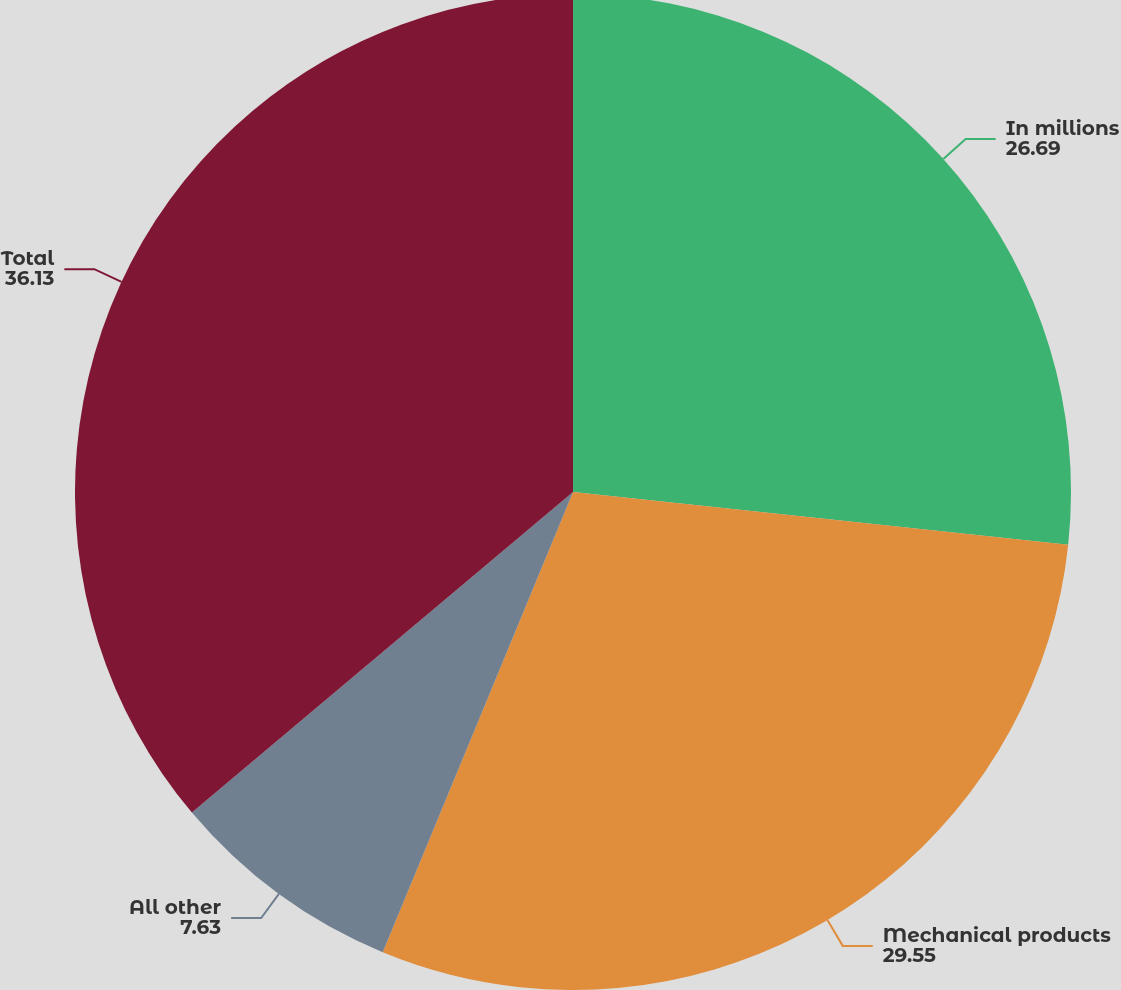<chart> <loc_0><loc_0><loc_500><loc_500><pie_chart><fcel>In millions<fcel>Mechanical products<fcel>All other<fcel>Total<nl><fcel>26.69%<fcel>29.55%<fcel>7.63%<fcel>36.13%<nl></chart> 